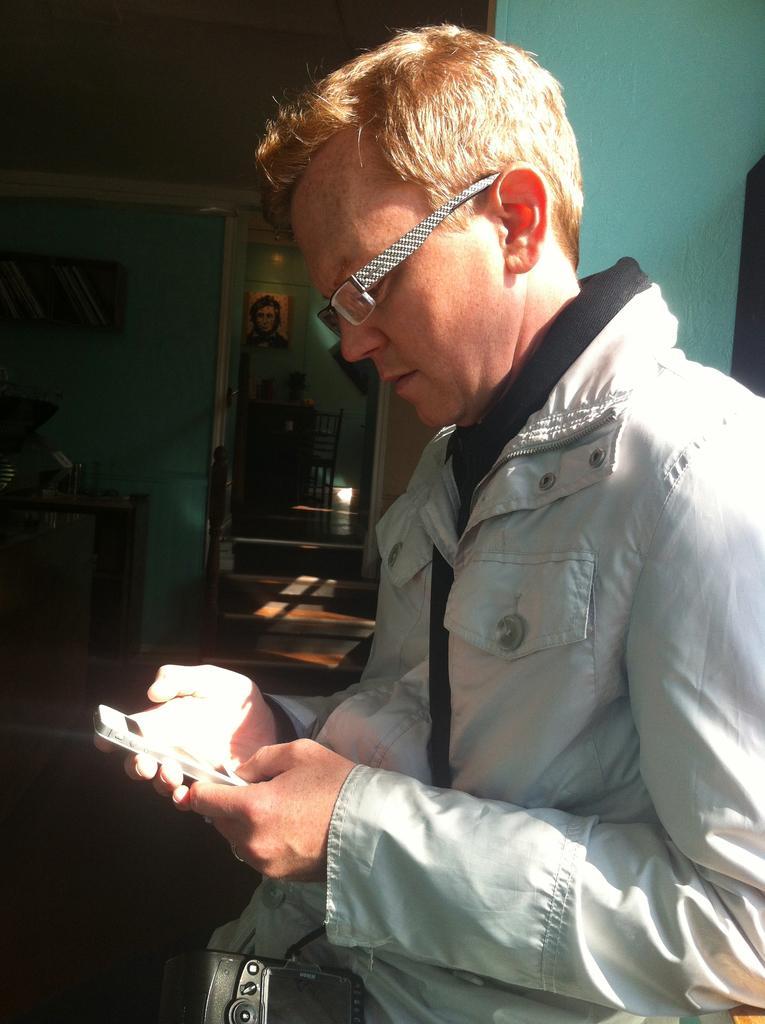Describe this image in one or two sentences. This man is holding a mobile and looking at this mobile. Picture is on wall. In this rack thee are books. On this table there are objects. Far there is a chair. 